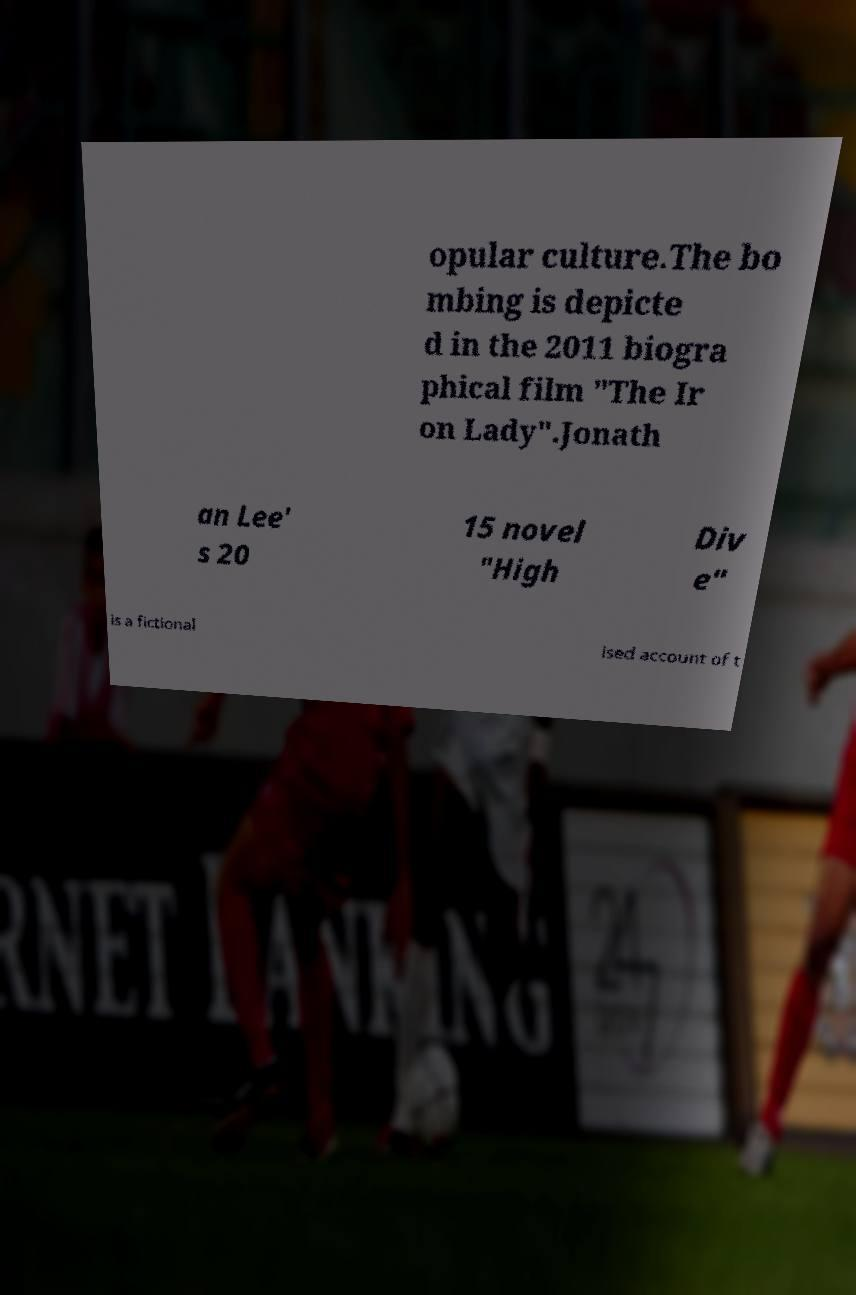What messages or text are displayed in this image? I need them in a readable, typed format. opular culture.The bo mbing is depicte d in the 2011 biogra phical film "The Ir on Lady".Jonath an Lee' s 20 15 novel "High Div e" is a fictional ised account of t 